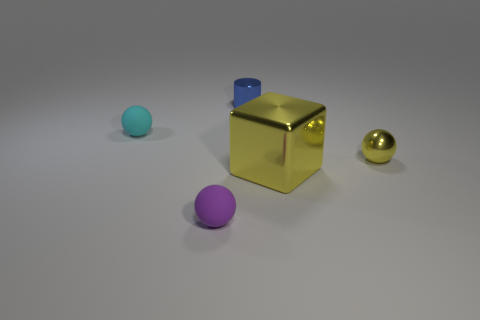Subtract all tiny matte balls. How many balls are left? 1 Add 1 cyan spheres. How many objects exist? 6 Subtract 2 spheres. How many spheres are left? 1 Subtract all green spheres. Subtract all brown blocks. How many spheres are left? 3 Subtract 1 purple spheres. How many objects are left? 4 Subtract all balls. How many objects are left? 2 Subtract all rubber balls. Subtract all tiny balls. How many objects are left? 0 Add 1 yellow cubes. How many yellow cubes are left? 2 Add 3 cyan cubes. How many cyan cubes exist? 3 